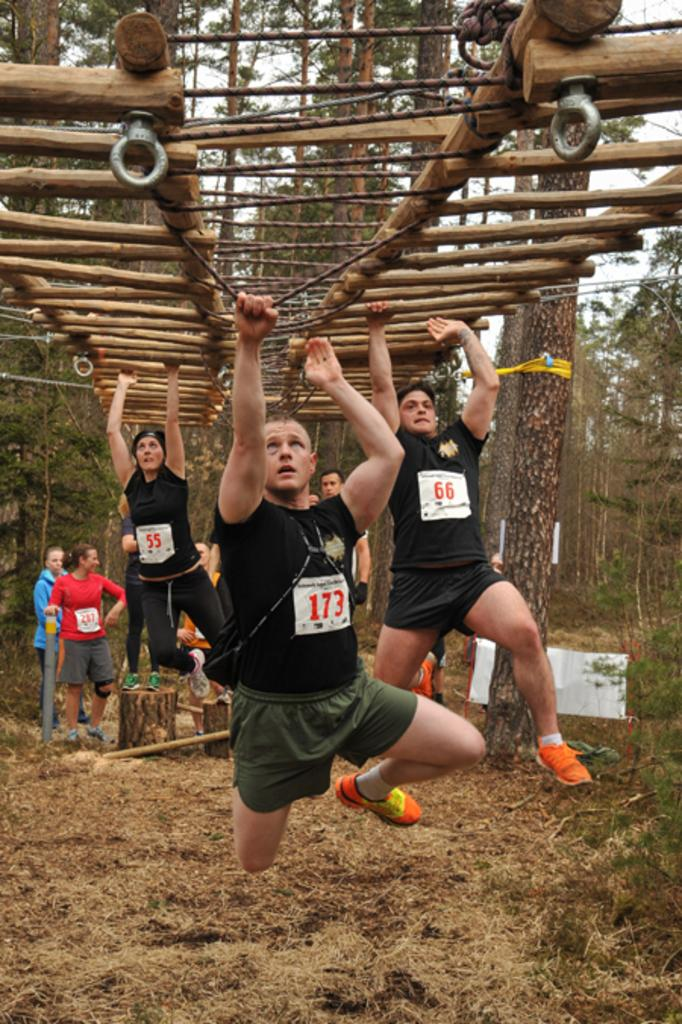<image>
Give a short and clear explanation of the subsequent image. A man with a black t-shirt and the number 173 on his chest is crossing the monkey bars. 